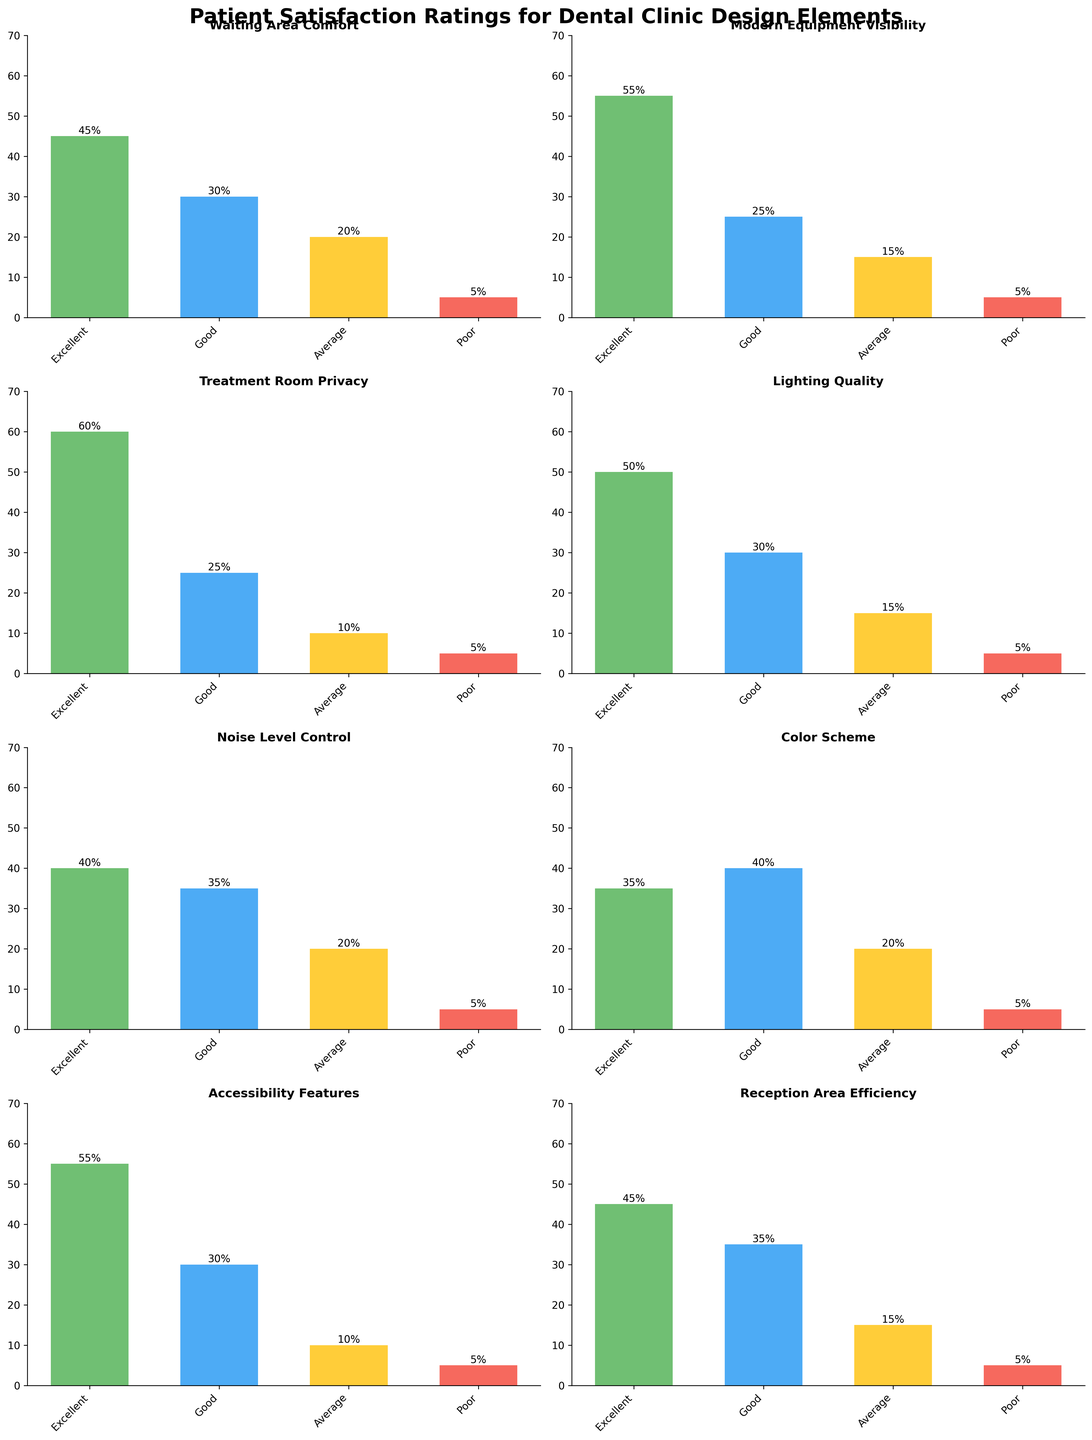What is the title of the chart? The chart title is written at the top of the figure in larger, bold font. It states the overall subject being analyzed.
Answer: Patient Satisfaction Ratings for Dental Clinic Design Elements How many design elements are rated in the chart? Each subplot represents a different design element rated by patients. Count the subplots to determine the number of elements.
Answer: 8 Which design element has the highest number of "Excellent" ratings? To find this, identify the bar with the highest value in the "Excellent" category across all subplots. This bar will be the tallest among all "Excellent" bars.
Answer: Treatment Room Privacy What is the combined number of “Poor” ratings for all design elements? Add the "Poor" ratings from each subplot to get the total.
Answer: 40 Which design element has the least “Good” ratings? Look at the height of the "Good" bars across all subplots and find the shortest one.
Answer: Accessibility Features Is the "Average" rating for Modern Equipment Visibility higher or lower than that for Reception Area Efficiency? Compare the heights of the "Average" bars for these two elements.
Answer: Higher Which two design elements have the same number of "Poor" ratings? Look for subplots with "Poor" bars of the same height and value.
Answer: Treatment Room Privacy and Modern Equipment Visibility What is the difference between the "Good" ratings of Color Scheme and Noise Level Control? Subtract the value of "Good" ratings for Color Scheme from that of Noise Level Control.
Answer: -5 Which design element shows the most balanced distribution across all rating categories? Compare the heights of the bars within each subplot. The one with the most similar heights for all bars is the most balanced.
Answer: Reception Area Efficiency What percentage of patients rated the Lighting Quality as “Good”? The percentage of "Good" ratings for Lighting Quality is indicated by the height of the respective bar.
Answer: 30% 